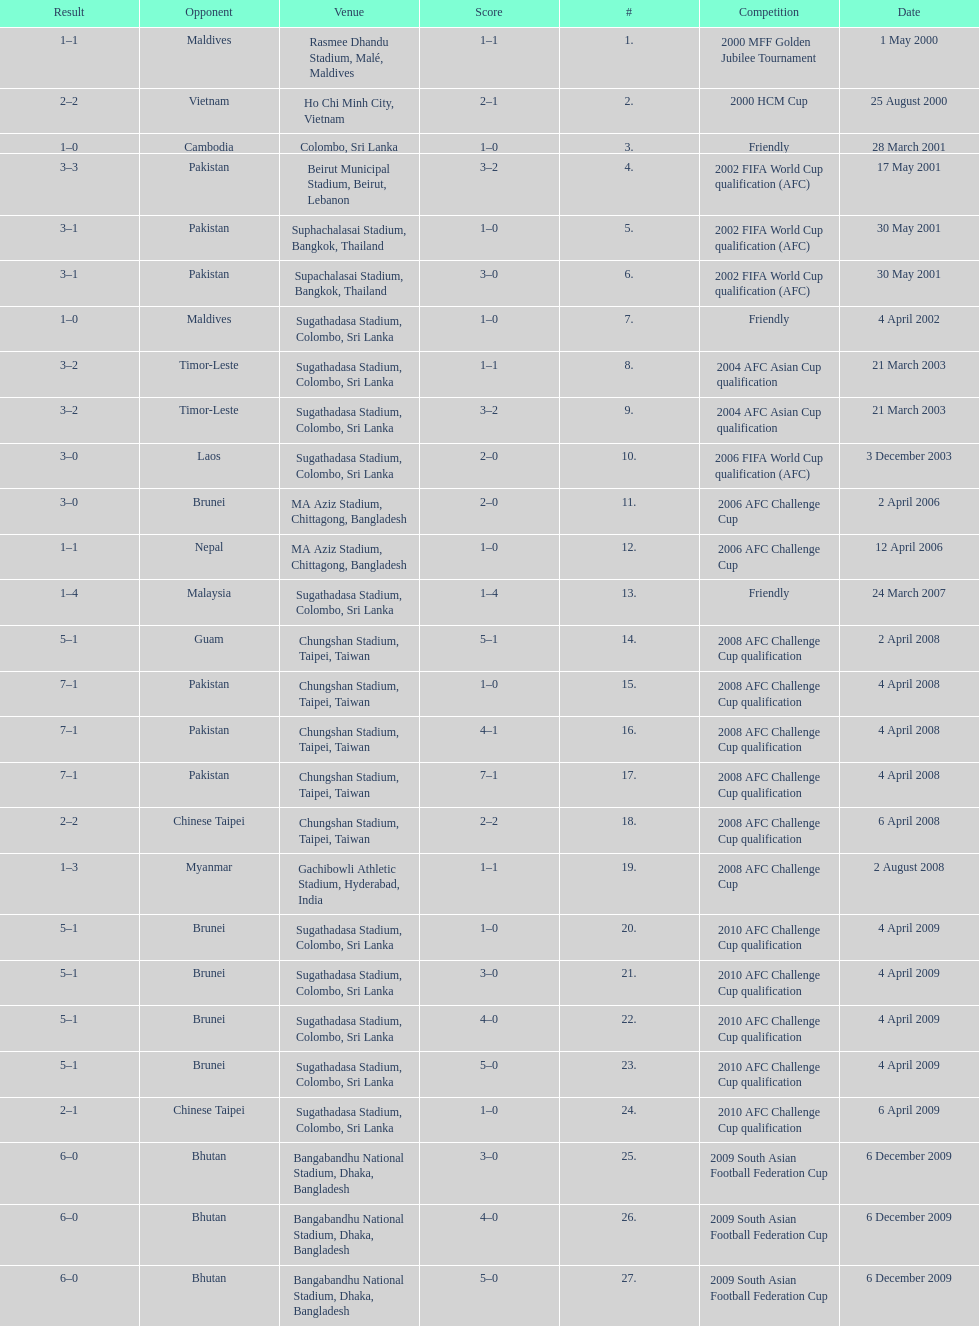Which venue has the largest result Chungshan Stadium, Taipei, Taiwan. 